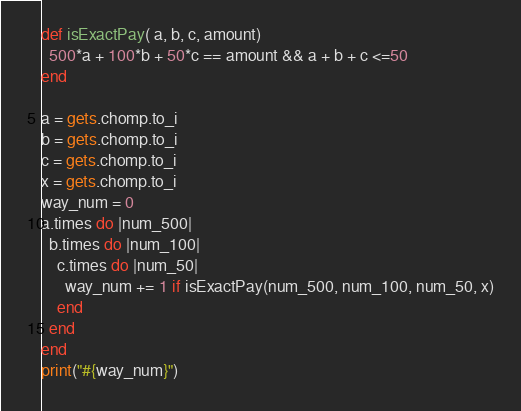<code> <loc_0><loc_0><loc_500><loc_500><_Ruby_>def isExactPay( a, b, c, amount)
  500*a + 100*b + 50*c == amount && a + b + c <=50
end

a = gets.chomp.to_i
b = gets.chomp.to_i
c = gets.chomp.to_i
x = gets.chomp.to_i
way_num = 0
a.times do |num_500|
  b.times do |num_100|
    c.times do |num_50|
      way_num += 1 if isExactPay(num_500, num_100, num_50, x)
    end
  end
end
print("#{way_num}")
</code> 